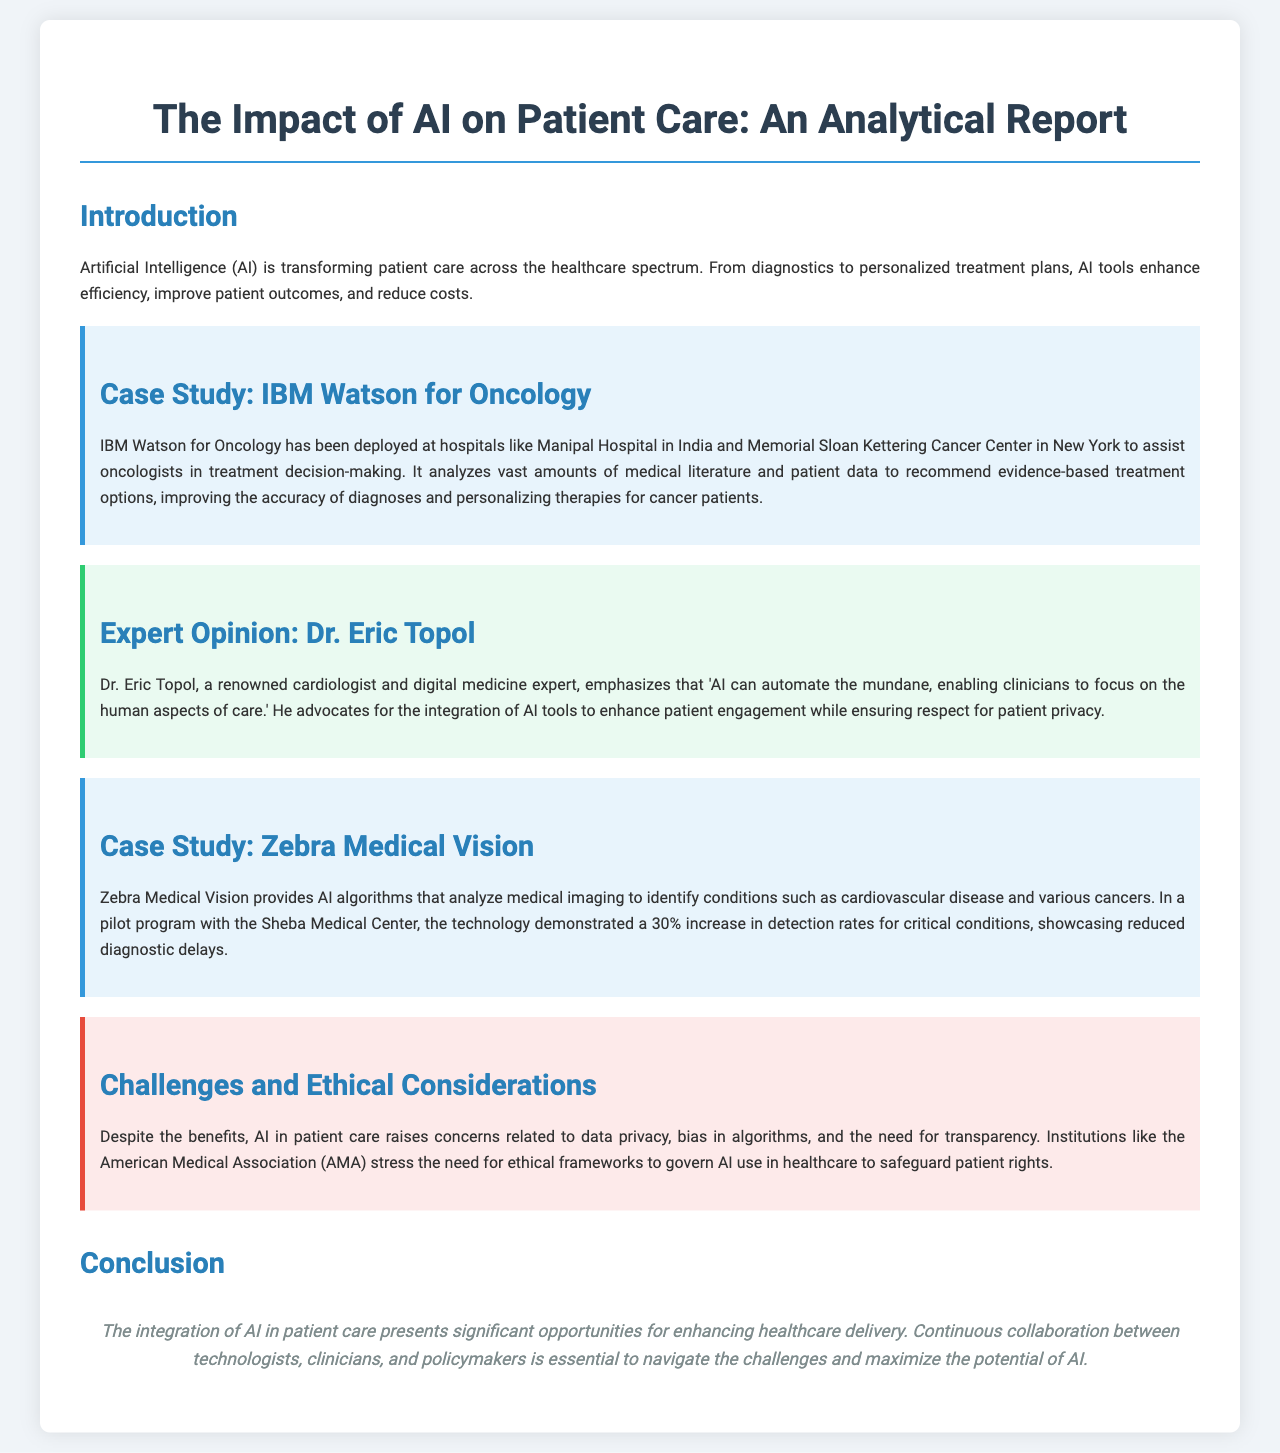What is the main topic of the report? The main topic discussed in the report is the impact of AI on patient care, particularly how it transforms healthcare delivery.
Answer: AI on patient care Who authored the case study on IBM Watson for Oncology? The document does not explicitly mention an author for the IBM Watson for Oncology case study; instead, it describes its deployment in hospitals.
Answer: IBM Watson for Oncology What percentage increase in detection rates did Zebra Medical Vision achieve? The document states that Zebra Medical Vision demonstrated a 30% increase in detection rates for critical conditions during its pilot program.
Answer: 30% Who is the expert quoted in the opinion section? Dr. Eric Topol is the expert whose opinion is quoted regarding AI's role in healthcare.
Answer: Dr. Eric Topol What are two challenges and ethical considerations mentioned in the report? The report mentions data privacy, bias in algorithms, and the need for transparency as challenges and ethical considerations.
Answer: Data privacy, bias What does Dr. Eric Topol advocate for regarding AI tools? Dr. Eric Topol advocates for the integration of AI tools to enhance patient engagement while ensuring respect for patient privacy.
Answer: Integration of AI tools What significant aspect of AI's potential in patient care is highlighted in the conclusion? The conclusion highlights the importance of continuous collaboration between technologists, clinicians, and policymakers to maximize AI's potential.
Answer: Continuous collaboration Where did the pilot program for Zebra Medical Vision take place? The pilot program for Zebra Medical Vision was conducted at the Sheba Medical Center.
Answer: Sheba Medical Center 